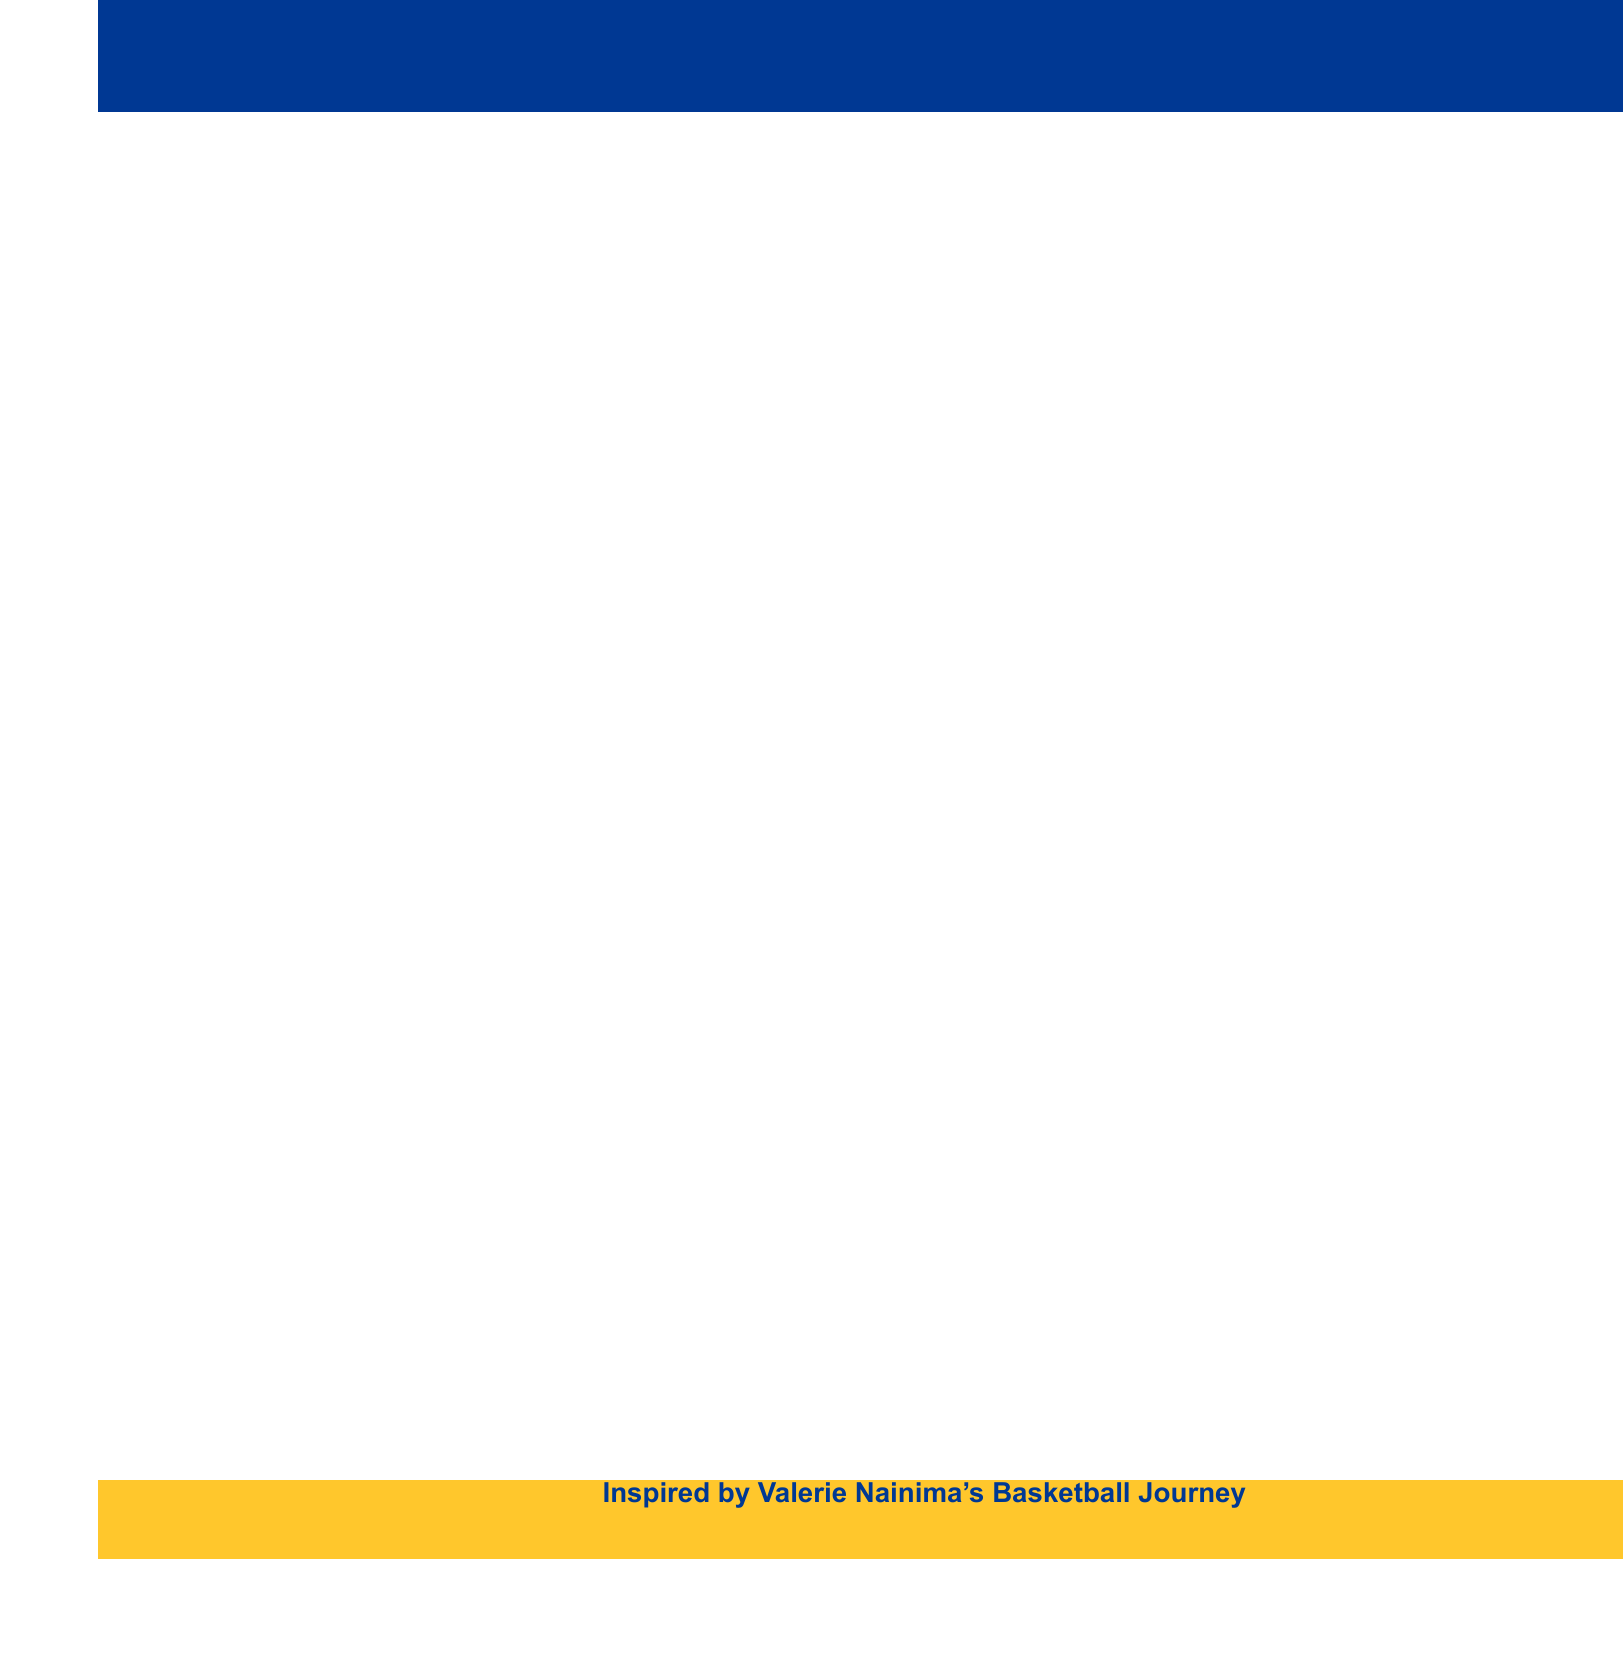What is the estimated cost for the indoor court at Vodafone Arena? The estimated cost for the indoor court at Vodafone Arena is mentioned in the document.
Answer: FJD 2,500,000 What is one potential funding source for upgrading outdoor courts? The document lists potential funding sources for the upgrade of outdoor courts.
Answer: Ministry of Education, Heritage and Arts How much is estimated for the basketball equipment for Nadi Sports Club? The document specifies the estimated cost for the basketball equipment for Nadi Sports Club.
Answer: FJD 75,000 What community engagement aspect is mentioned in the document? The document emphasizes involving local communities in the planning and maintenance of facilities.
Answer: Involve local communities What is the total estimated cost for the youth development center at Lawaqa Park? The document provides the estimated cost for building the youth development center at Lawaqa Park.
Answer: FJD 1,200,000 Which organization is suggested as a funding source for basketball equipment in Nadi? The document lists organizations that may provide funding for basketball equipment at Nadi Sports Club.
Answer: Fiji Airways community outreach program What consideration is made for accessibility in new facilities? The document highlights the need for facilities to be accessible to players with disabilities.
Answer: Accessible to players with disabilities What is the purpose of this memo? The document states the overall purpose of outlining upgrades and improvements needed for facilities.
Answer: Upgrades for basketball facilities in Fiji What sustainable practice is referenced in the additional considerations? The document discusses environmental considerations within facility upgrades.
Answer: Eco-friendly materials and energy-efficient designs 